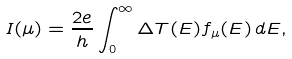Convert formula to latex. <formula><loc_0><loc_0><loc_500><loc_500>I ( \mu ) = \frac { 2 e } { h } \int _ { 0 } ^ { \infty } \Delta T ( E ) f _ { \mu } ( E ) \, d E ,</formula> 